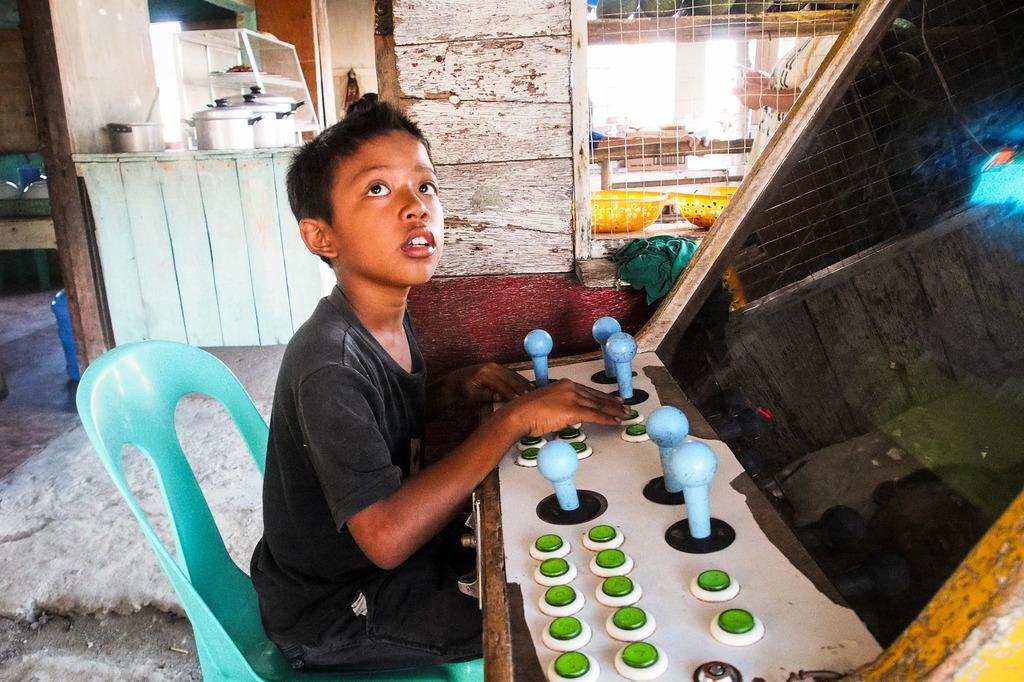Can you describe this image briefly? In this picture I can see there is a kid sitting on the chair and there is an object at right side with buttons. In the backdrop, there are few vessels and a wooden wall. 